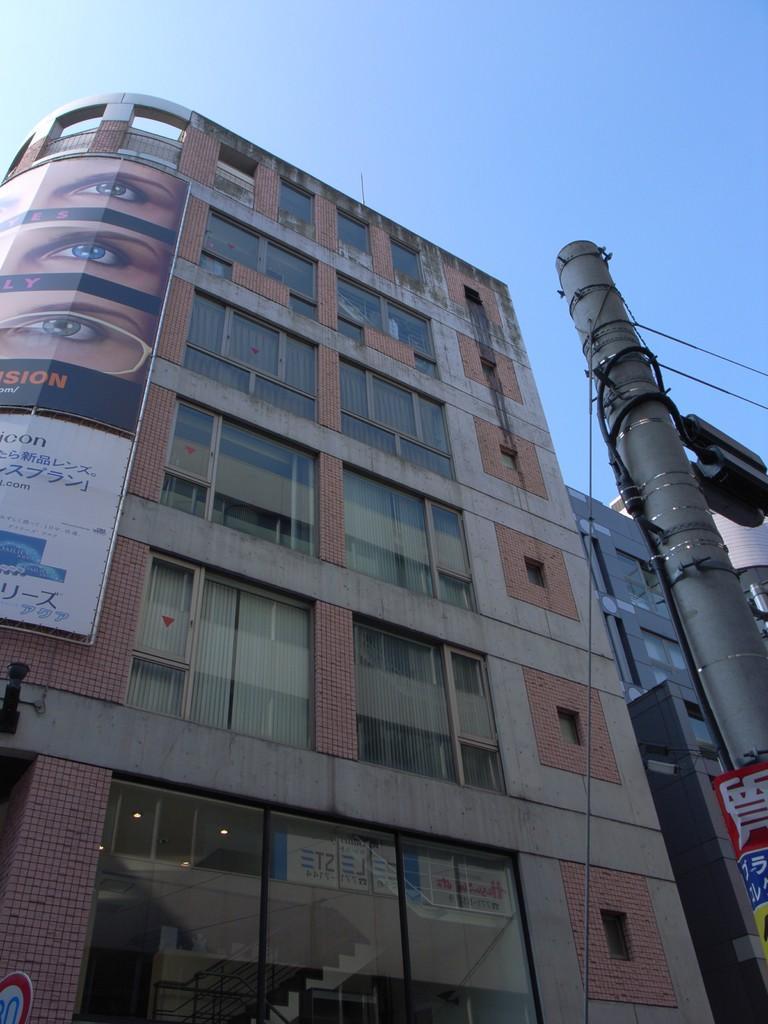Please provide a concise description of this image. On the left there are cables, street light and a pole. In the center of the picture there are buildings with glass windows and brick walls. On the left there is a banner. Sky is clear. 